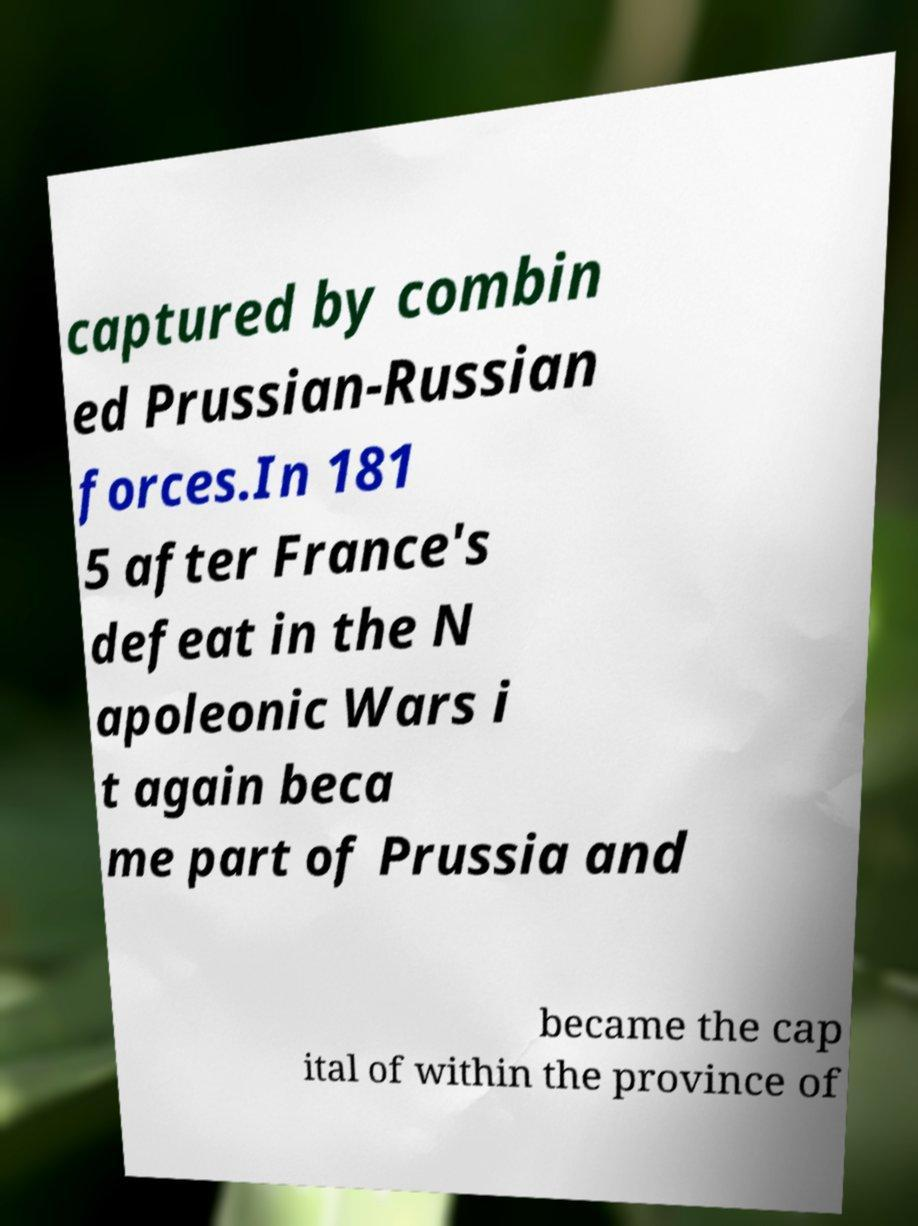I need the written content from this picture converted into text. Can you do that? captured by combin ed Prussian-Russian forces.In 181 5 after France's defeat in the N apoleonic Wars i t again beca me part of Prussia and became the cap ital of within the province of 